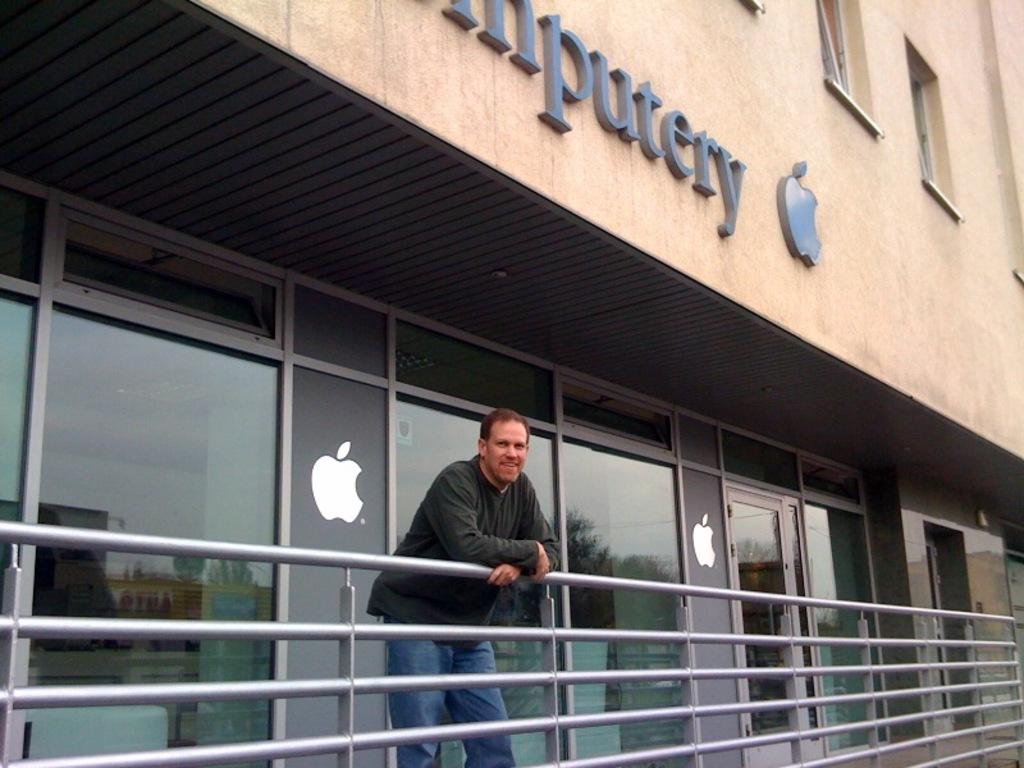What is the main subject of the image? There is a man standing in the image. What can be seen in the background of the image? There is a building in the image. What is the man holding in the image? There are glass objects with reflections in the image. What do the reflections in the glass objects show? The reflections include trees, buildings, and the sky. Are there any other objects present in the image? Yes, there are railing in the image. What color are the balls being juggled by the man in the image? There are no balls present in the image, and the man is not juggling anything. 